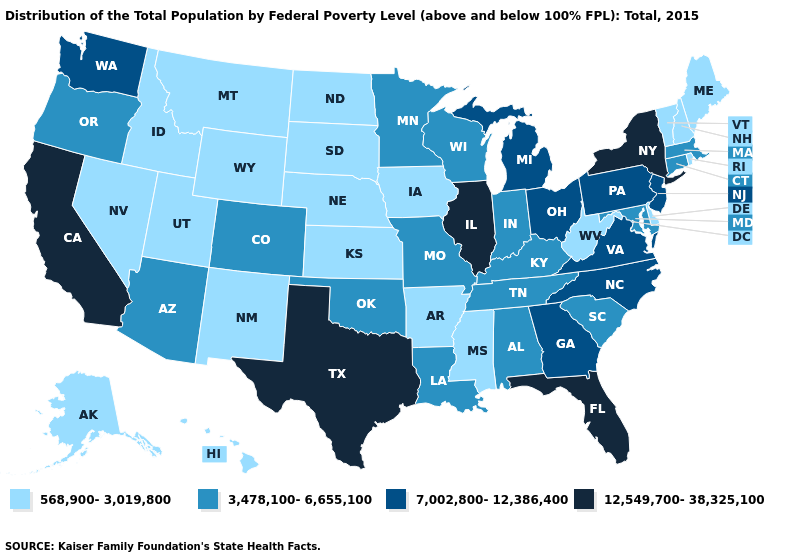What is the value of Kansas?
Be succinct. 568,900-3,019,800. Does Hawaii have the lowest value in the USA?
Answer briefly. Yes. Which states hav the highest value in the West?
Answer briefly. California. Among the states that border Idaho , does Washington have the lowest value?
Write a very short answer. No. Name the states that have a value in the range 7,002,800-12,386,400?
Short answer required. Georgia, Michigan, New Jersey, North Carolina, Ohio, Pennsylvania, Virginia, Washington. Is the legend a continuous bar?
Keep it brief. No. Name the states that have a value in the range 3,478,100-6,655,100?
Quick response, please. Alabama, Arizona, Colorado, Connecticut, Indiana, Kentucky, Louisiana, Maryland, Massachusetts, Minnesota, Missouri, Oklahoma, Oregon, South Carolina, Tennessee, Wisconsin. Does Illinois have the highest value in the USA?
Be succinct. Yes. Among the states that border Wisconsin , which have the highest value?
Concise answer only. Illinois. Which states have the highest value in the USA?
Keep it brief. California, Florida, Illinois, New York, Texas. What is the value of Missouri?
Concise answer only. 3,478,100-6,655,100. Among the states that border Connecticut , which have the lowest value?
Answer briefly. Rhode Island. What is the value of Rhode Island?
Answer briefly. 568,900-3,019,800. Does Arizona have the highest value in the West?
Keep it brief. No. Does Maine have the lowest value in the Northeast?
Quick response, please. Yes. 